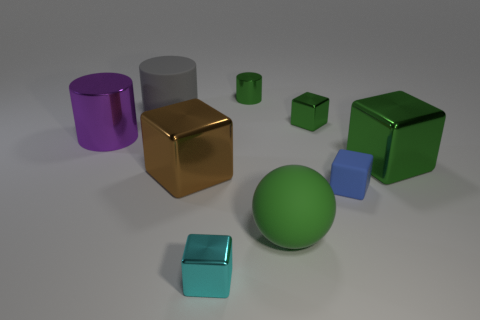How many other objects are the same color as the large matte ball?
Offer a terse response. 3. What is the small green cylinder made of?
Keep it short and to the point. Metal. What is the material of the big thing that is to the right of the brown thing and in front of the big green metallic cube?
Provide a succinct answer. Rubber. What number of things are small shiny objects behind the purple cylinder or large red metallic objects?
Give a very brief answer. 2. Is the color of the tiny metal cylinder the same as the small matte thing?
Provide a succinct answer. No. Is there a purple cube of the same size as the brown metallic cube?
Give a very brief answer. No. How many blocks are on the left side of the large green metallic cube and right of the small green metal cube?
Give a very brief answer. 1. There is a purple cylinder; how many big brown blocks are behind it?
Make the answer very short. 0. Is there a big yellow matte object that has the same shape as the blue thing?
Keep it short and to the point. No. Does the big purple metal object have the same shape as the matte object that is to the left of the cyan metal cube?
Give a very brief answer. Yes. 